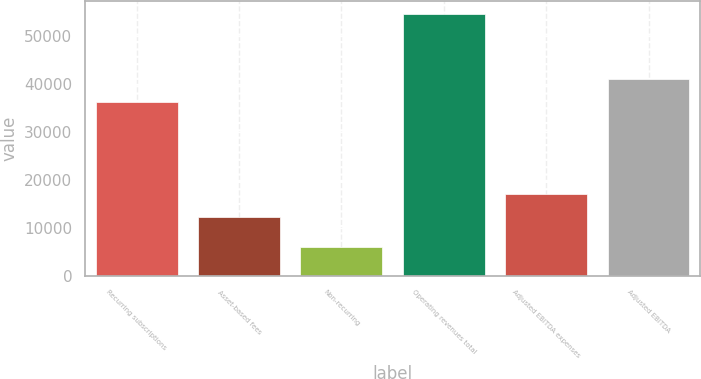Convert chart. <chart><loc_0><loc_0><loc_500><loc_500><bar_chart><fcel>Recurring subscriptions<fcel>Asset-based fees<fcel>Non-recurring<fcel>Operating revenues total<fcel>Adjusted EBITDA expenses<fcel>Adjusted EBITDA<nl><fcel>36212<fcel>12255<fcel>6120<fcel>54587<fcel>17101.7<fcel>41058.7<nl></chart> 